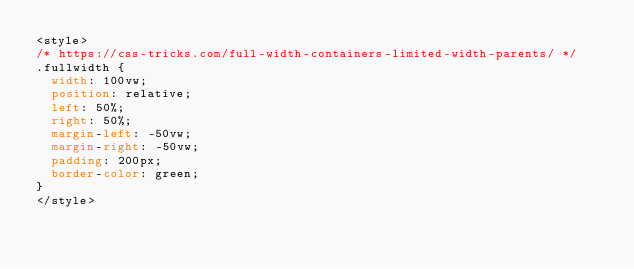Convert code to text. <code><loc_0><loc_0><loc_500><loc_500><_CSS_><style>
/* https://css-tricks.com/full-width-containers-limited-width-parents/ */
.fullwidth {
  width: 100vw;
  position: relative;
  left: 50%;
  right: 50%;
  margin-left: -50vw;
  margin-right: -50vw;
  padding: 200px;
  border-color: green;
}
</style>
</code> 